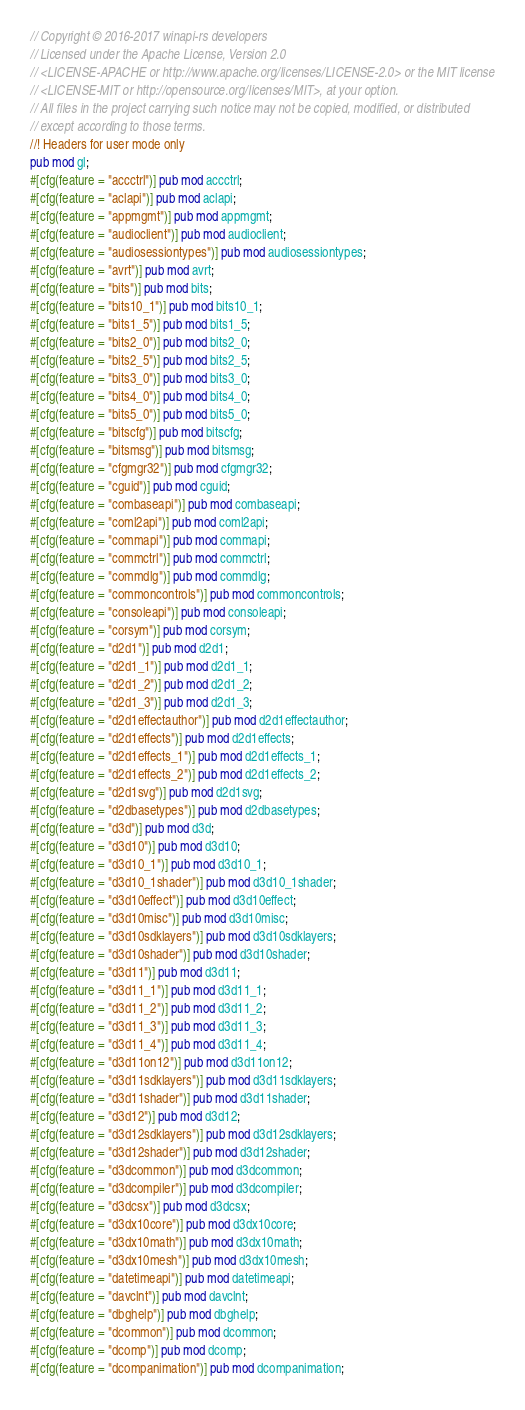<code> <loc_0><loc_0><loc_500><loc_500><_Rust_>// Copyright © 2016-2017 winapi-rs developers
// Licensed under the Apache License, Version 2.0
// <LICENSE-APACHE or http://www.apache.org/licenses/LICENSE-2.0> or the MIT license
// <LICENSE-MIT or http://opensource.org/licenses/MIT>, at your option.
// All files in the project carrying such notice may not be copied, modified, or distributed
// except according to those terms.
//! Headers for user mode only
pub mod gl;
#[cfg(feature = "accctrl")] pub mod accctrl;
#[cfg(feature = "aclapi")] pub mod aclapi;
#[cfg(feature = "appmgmt")] pub mod appmgmt;
#[cfg(feature = "audioclient")] pub mod audioclient;
#[cfg(feature = "audiosessiontypes")] pub mod audiosessiontypes;
#[cfg(feature = "avrt")] pub mod avrt;
#[cfg(feature = "bits")] pub mod bits;
#[cfg(feature = "bits10_1")] pub mod bits10_1;
#[cfg(feature = "bits1_5")] pub mod bits1_5;
#[cfg(feature = "bits2_0")] pub mod bits2_0;
#[cfg(feature = "bits2_5")] pub mod bits2_5;
#[cfg(feature = "bits3_0")] pub mod bits3_0;
#[cfg(feature = "bits4_0")] pub mod bits4_0;
#[cfg(feature = "bits5_0")] pub mod bits5_0;
#[cfg(feature = "bitscfg")] pub mod bitscfg;
#[cfg(feature = "bitsmsg")] pub mod bitsmsg;
#[cfg(feature = "cfgmgr32")] pub mod cfgmgr32;
#[cfg(feature = "cguid")] pub mod cguid;
#[cfg(feature = "combaseapi")] pub mod combaseapi;
#[cfg(feature = "coml2api")] pub mod coml2api;
#[cfg(feature = "commapi")] pub mod commapi;
#[cfg(feature = "commctrl")] pub mod commctrl;
#[cfg(feature = "commdlg")] pub mod commdlg;
#[cfg(feature = "commoncontrols")] pub mod commoncontrols;
#[cfg(feature = "consoleapi")] pub mod consoleapi;
#[cfg(feature = "corsym")] pub mod corsym;
#[cfg(feature = "d2d1")] pub mod d2d1;
#[cfg(feature = "d2d1_1")] pub mod d2d1_1;
#[cfg(feature = "d2d1_2")] pub mod d2d1_2;
#[cfg(feature = "d2d1_3")] pub mod d2d1_3;
#[cfg(feature = "d2d1effectauthor")] pub mod d2d1effectauthor;
#[cfg(feature = "d2d1effects")] pub mod d2d1effects;
#[cfg(feature = "d2d1effects_1")] pub mod d2d1effects_1;
#[cfg(feature = "d2d1effects_2")] pub mod d2d1effects_2;
#[cfg(feature = "d2d1svg")] pub mod d2d1svg;
#[cfg(feature = "d2dbasetypes")] pub mod d2dbasetypes;
#[cfg(feature = "d3d")] pub mod d3d;
#[cfg(feature = "d3d10")] pub mod d3d10;
#[cfg(feature = "d3d10_1")] pub mod d3d10_1;
#[cfg(feature = "d3d10_1shader")] pub mod d3d10_1shader;
#[cfg(feature = "d3d10effect")] pub mod d3d10effect;
#[cfg(feature = "d3d10misc")] pub mod d3d10misc;
#[cfg(feature = "d3d10sdklayers")] pub mod d3d10sdklayers;
#[cfg(feature = "d3d10shader")] pub mod d3d10shader;
#[cfg(feature = "d3d11")] pub mod d3d11;
#[cfg(feature = "d3d11_1")] pub mod d3d11_1;
#[cfg(feature = "d3d11_2")] pub mod d3d11_2;
#[cfg(feature = "d3d11_3")] pub mod d3d11_3;
#[cfg(feature = "d3d11_4")] pub mod d3d11_4;
#[cfg(feature = "d3d11on12")] pub mod d3d11on12;
#[cfg(feature = "d3d11sdklayers")] pub mod d3d11sdklayers;
#[cfg(feature = "d3d11shader")] pub mod d3d11shader;
#[cfg(feature = "d3d12")] pub mod d3d12;
#[cfg(feature = "d3d12sdklayers")] pub mod d3d12sdklayers;
#[cfg(feature = "d3d12shader")] pub mod d3d12shader;
#[cfg(feature = "d3dcommon")] pub mod d3dcommon;
#[cfg(feature = "d3dcompiler")] pub mod d3dcompiler;
#[cfg(feature = "d3dcsx")] pub mod d3dcsx;
#[cfg(feature = "d3dx10core")] pub mod d3dx10core;
#[cfg(feature = "d3dx10math")] pub mod d3dx10math;
#[cfg(feature = "d3dx10mesh")] pub mod d3dx10mesh;
#[cfg(feature = "datetimeapi")] pub mod datetimeapi;
#[cfg(feature = "davclnt")] pub mod davclnt;
#[cfg(feature = "dbghelp")] pub mod dbghelp;
#[cfg(feature = "dcommon")] pub mod dcommon;
#[cfg(feature = "dcomp")] pub mod dcomp;
#[cfg(feature = "dcompanimation")] pub mod dcompanimation;</code> 